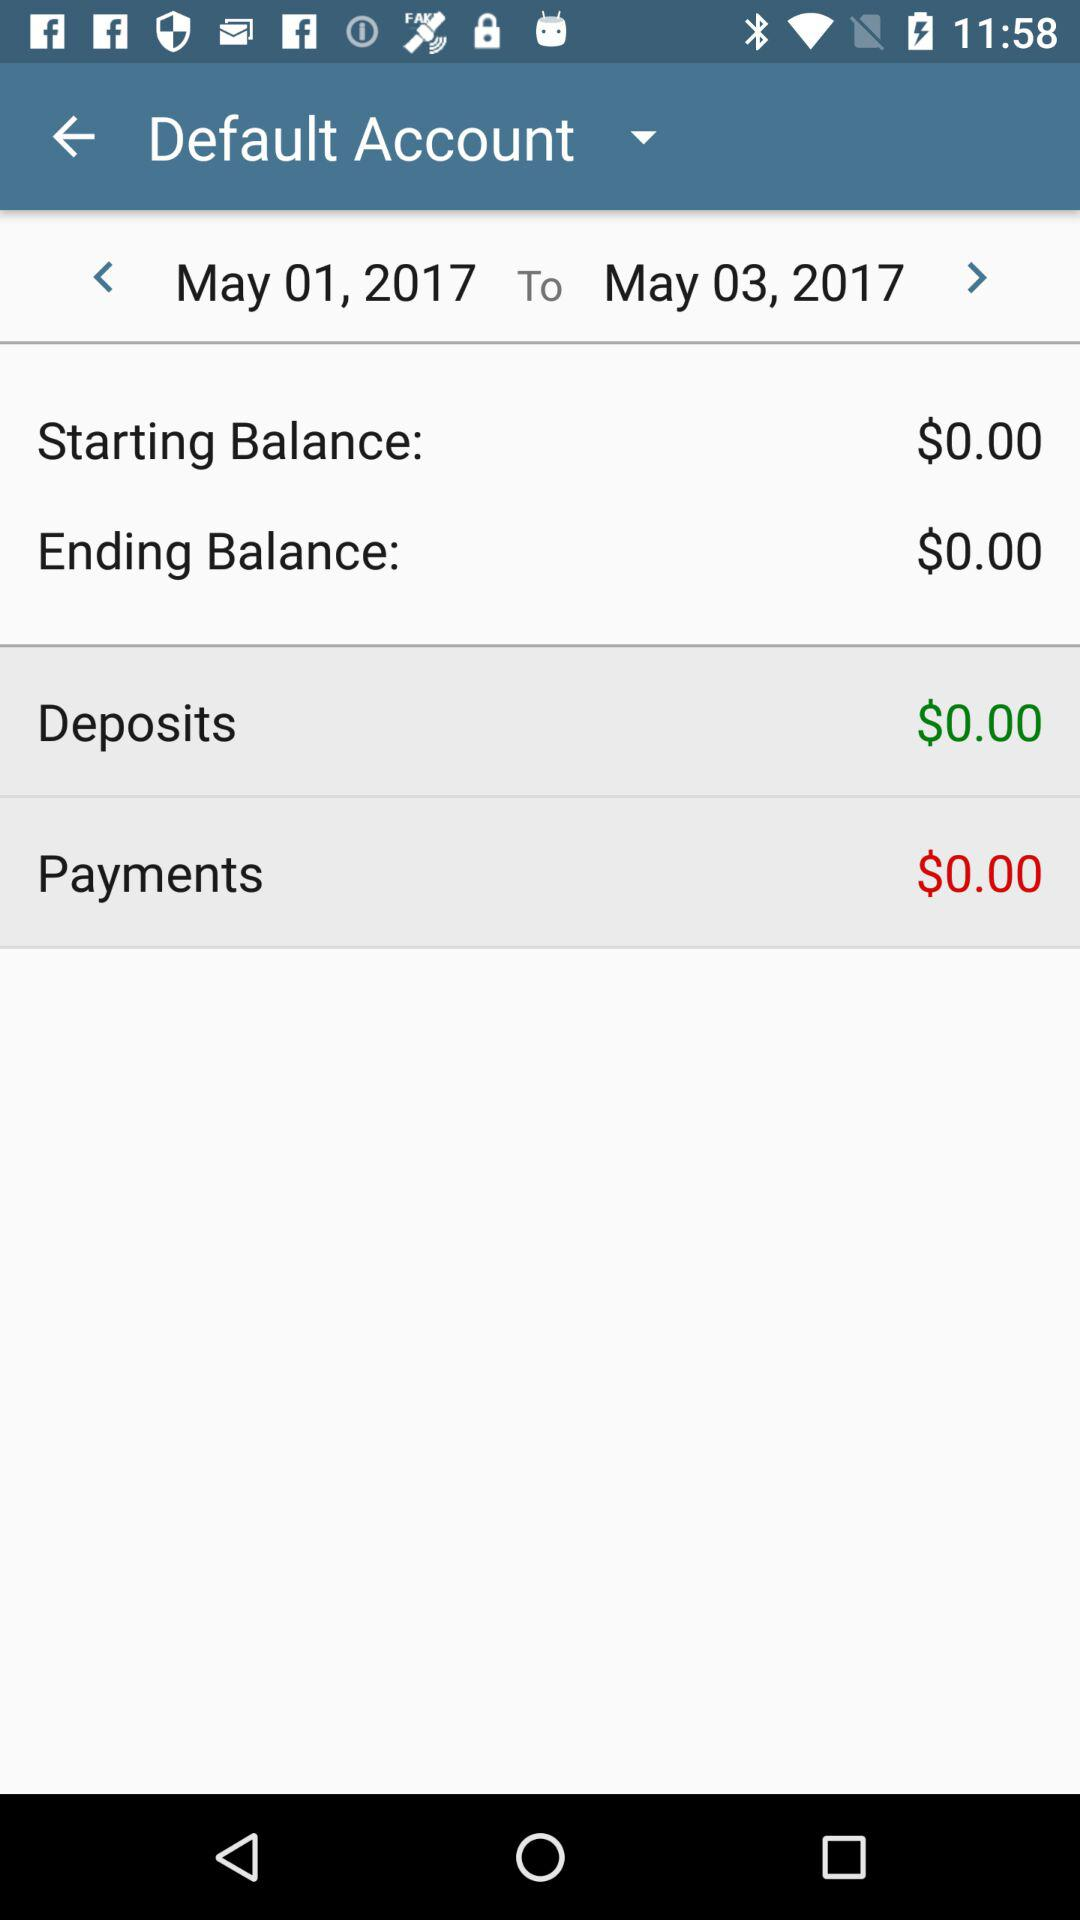What is the starting balance? The starting balance is $0. 